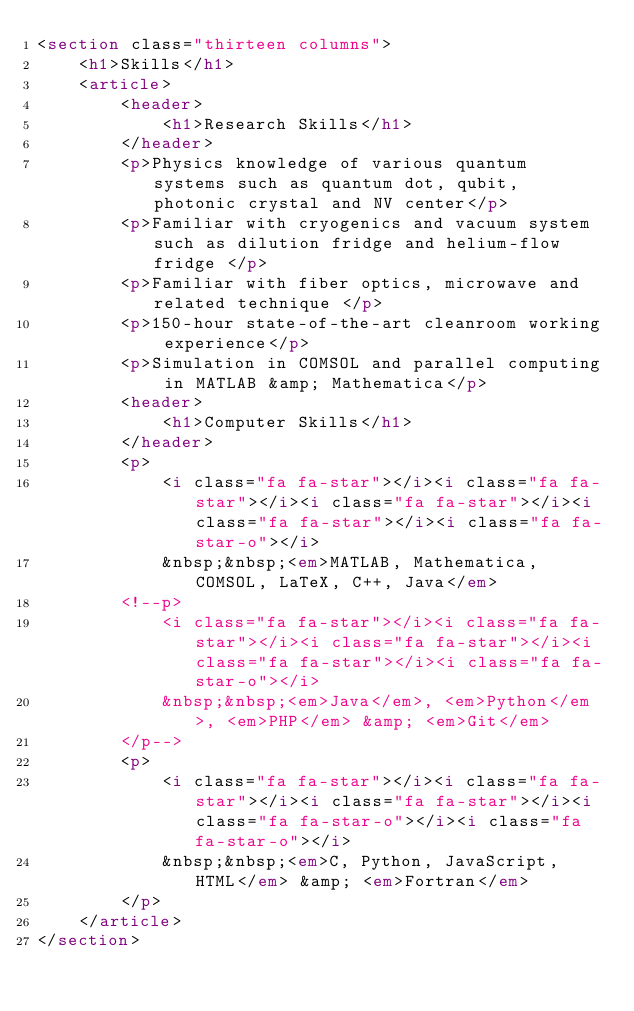<code> <loc_0><loc_0><loc_500><loc_500><_HTML_><section class="thirteen columns">
    <h1>Skills</h1>
    <article>
        <header>
            <h1>Research Skills</h1>
        </header>
        <p>Physics knowledge of various quantum systems such as quantum dot, qubit, photonic crystal and NV center</p>
        <p>Familiar with cryogenics and vacuum system such as dilution fridge and helium-flow fridge </p>
        <p>Familiar with fiber optics, microwave and related technique </p>
        <p>150-hour state-of-the-art cleanroom working experience</p>
        <p>Simulation in COMSOL and parallel computing in MATLAB &amp; Mathematica</p>
        <header>
            <h1>Computer Skills</h1>
        </header>
        <p>
            <i class="fa fa-star"></i><i class="fa fa-star"></i><i class="fa fa-star"></i><i class="fa fa-star"></i><i class="fa fa-star-o"></i>
            &nbsp;&nbsp;<em>MATLAB, Mathematica, COMSOL, LaTeX, C++, Java</em>
        <!--p>
            <i class="fa fa-star"></i><i class="fa fa-star"></i><i class="fa fa-star"></i><i class="fa fa-star"></i><i class="fa fa-star-o"></i>
            &nbsp;&nbsp;<em>Java</em>, <em>Python</em>, <em>PHP</em> &amp; <em>Git</em>
        </p-->
        <p>
            <i class="fa fa-star"></i><i class="fa fa-star"></i><i class="fa fa-star"></i><i class="fa fa-star-o"></i><i class="fa fa-star-o"></i>
            &nbsp;&nbsp;<em>C, Python, JavaScript, HTML</em> &amp; <em>Fortran</em>
        </p>
    </article>
</section></code> 